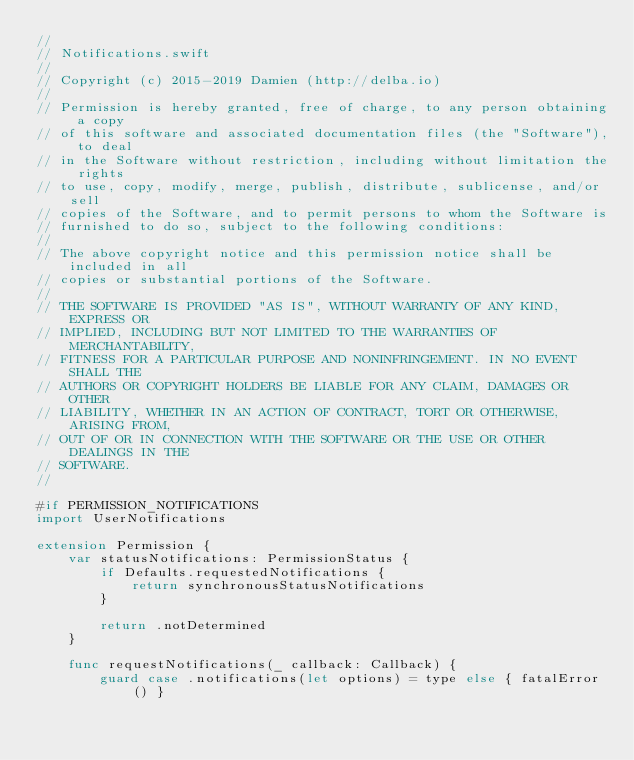Convert code to text. <code><loc_0><loc_0><loc_500><loc_500><_Swift_>//
// Notifications.swift
//
// Copyright (c) 2015-2019 Damien (http://delba.io)
//
// Permission is hereby granted, free of charge, to any person obtaining a copy
// of this software and associated documentation files (the "Software"), to deal
// in the Software without restriction, including without limitation the rights
// to use, copy, modify, merge, publish, distribute, sublicense, and/or sell
// copies of the Software, and to permit persons to whom the Software is
// furnished to do so, subject to the following conditions:
//
// The above copyright notice and this permission notice shall be included in all
// copies or substantial portions of the Software.
//
// THE SOFTWARE IS PROVIDED "AS IS", WITHOUT WARRANTY OF ANY KIND, EXPRESS OR
// IMPLIED, INCLUDING BUT NOT LIMITED TO THE WARRANTIES OF MERCHANTABILITY,
// FITNESS FOR A PARTICULAR PURPOSE AND NONINFRINGEMENT. IN NO EVENT SHALL THE
// AUTHORS OR COPYRIGHT HOLDERS BE LIABLE FOR ANY CLAIM, DAMAGES OR OTHER
// LIABILITY, WHETHER IN AN ACTION OF CONTRACT, TORT OR OTHERWISE, ARISING FROM,
// OUT OF OR IN CONNECTION WITH THE SOFTWARE OR THE USE OR OTHER DEALINGS IN THE
// SOFTWARE.
//

#if PERMISSION_NOTIFICATIONS
import UserNotifications

extension Permission {
    var statusNotifications: PermissionStatus {
        if Defaults.requestedNotifications {
            return synchronousStatusNotifications
        }

        return .notDetermined
    }

    func requestNotifications(_ callback: Callback) {
        guard case .notifications(let options) = type else { fatalError() }
</code> 